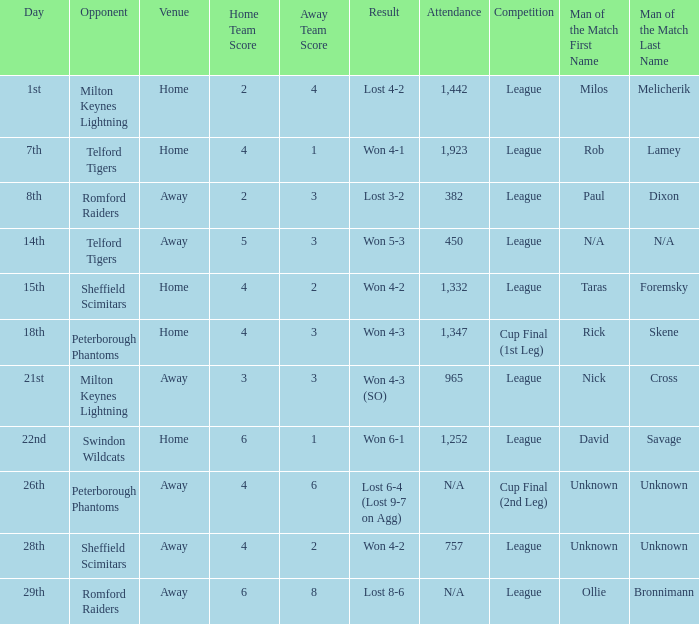What was the result on the 26th? Lost 6-4 (Lost 9-7 on Agg). 